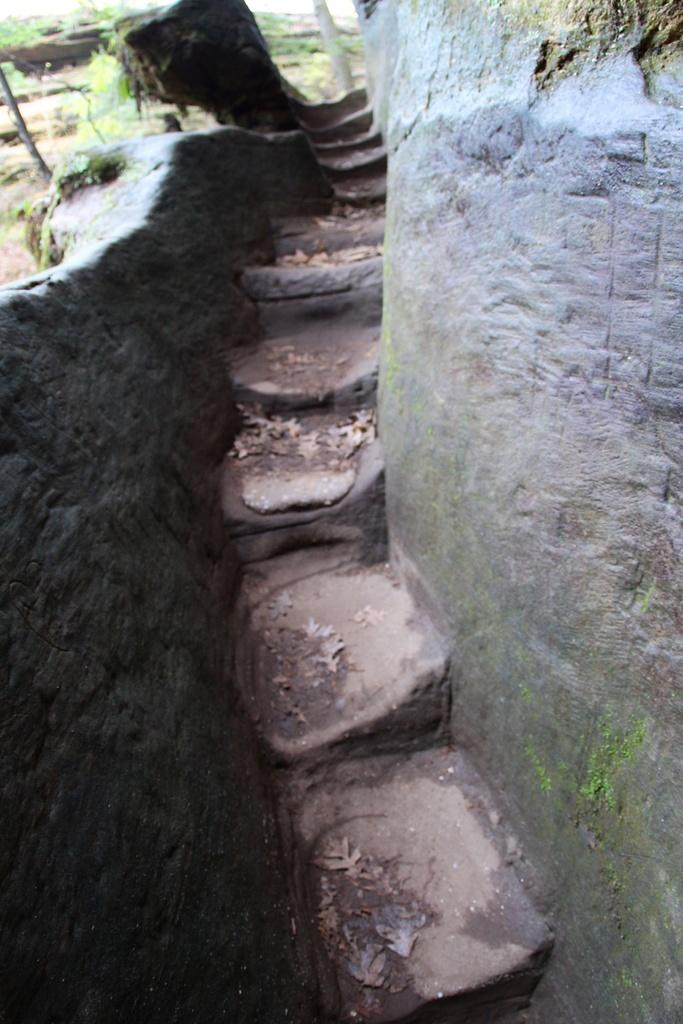What is the main feature in the center of the image? There are stairs in the center of the image. What can be seen on the left side of the image? There is a wall on the left side of the image. What is on the opposite side of the image? There is a wall on the right side of the image. What type of natural environment is visible in the background of the image? There is grass visible in the background of the image. How many kittens are playing on the stairs in the image? There are no kittens present in the image; it only features stairs, walls, and grass in the background. 